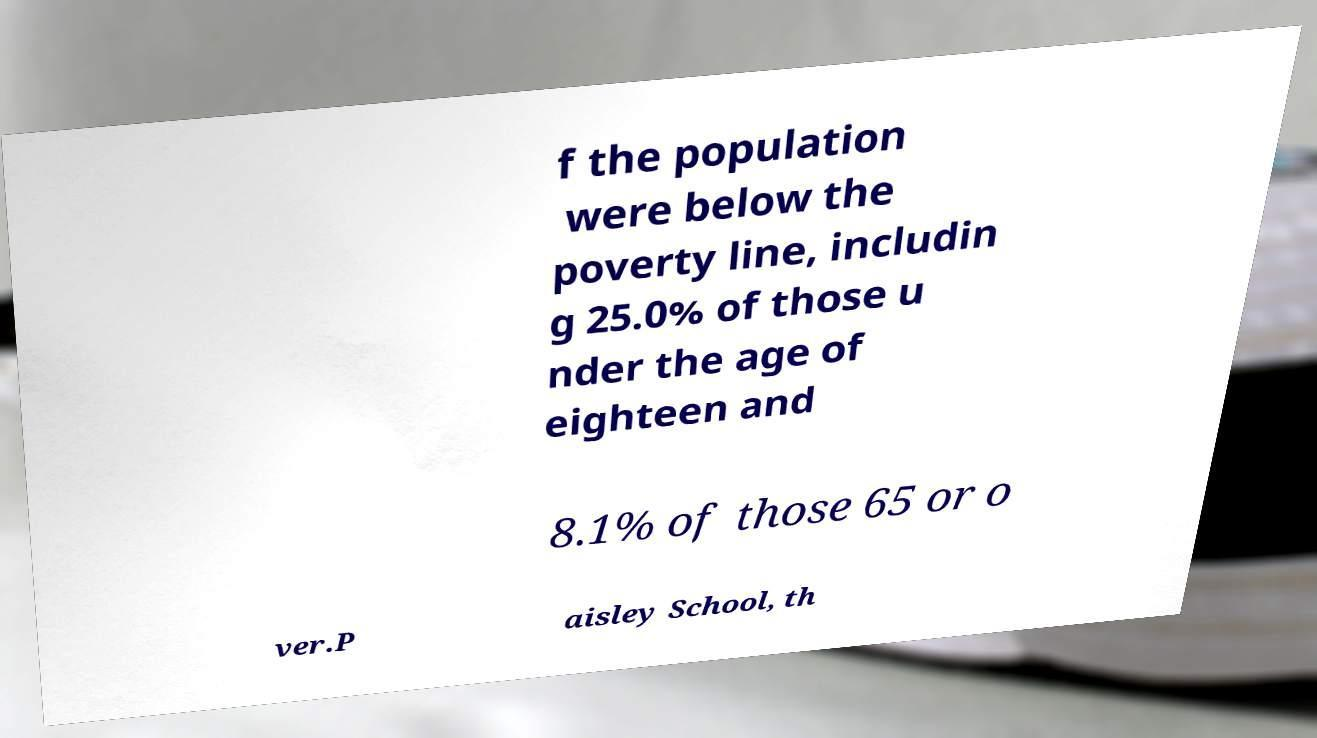Please identify and transcribe the text found in this image. f the population were below the poverty line, includin g 25.0% of those u nder the age of eighteen and 8.1% of those 65 or o ver.P aisley School, th 